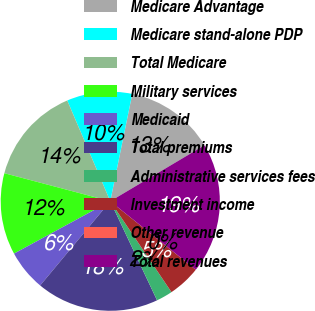Convert chart. <chart><loc_0><loc_0><loc_500><loc_500><pie_chart><fcel>Medicare Advantage<fcel>Medicare stand-alone PDP<fcel>Total Medicare<fcel>Military services<fcel>Medicaid<fcel>Total premiums<fcel>Administrative services fees<fcel>Investment income<fcel>Other revenue<fcel>Total revenues<nl><fcel>13.25%<fcel>9.64%<fcel>14.46%<fcel>12.05%<fcel>6.02%<fcel>18.07%<fcel>2.41%<fcel>4.82%<fcel>0.0%<fcel>19.28%<nl></chart> 